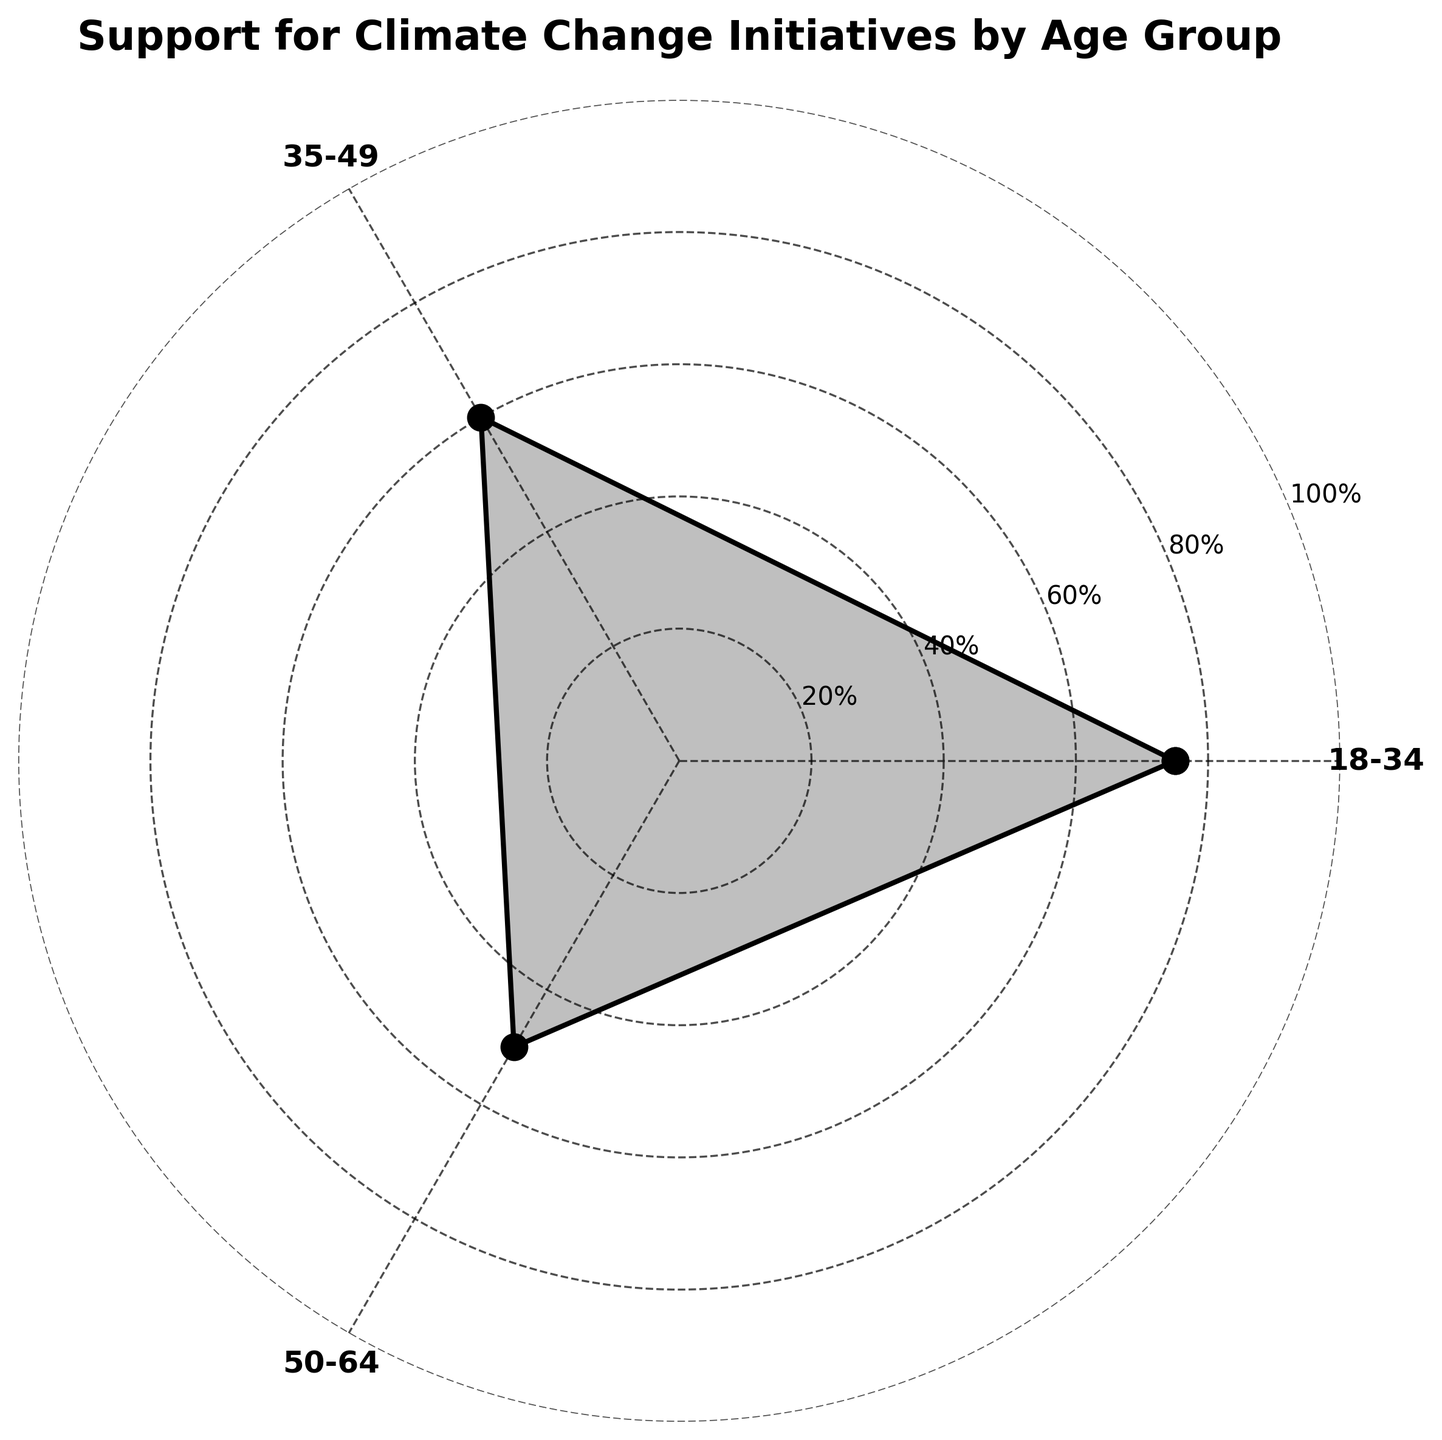What is the title of the figure? The title is displayed at the top of the figure and it reads "Support for Climate Change Initiatives by Age Group".
Answer: Support for Climate Change Initiatives by Age Group Which age group has the highest support level for climate change initiatives? By examining the plot, the highest point on the radial axis corresponds to the age group "18-34" with a support level of 75%.
Answer: 18-34 What are the age groups displayed in the rose chart? The categories along the angles show the age groups "18-34", "35-49", and "50-64".
Answer: 18-34, 35-49, 50-64 What is the support level for the age group 35-49? By looking at the position on the radial axis for the age group "35-49", the support level is shown as 60%.
Answer: 60% How many age groups are visualized in the figure? The rose chart represents three different age groups.
Answer: Three Which age group shows the least support for climate change initiatives among the visualized groups? The lowest point on the radial axis corresponds to the age group "50-64" with a support level of 50%.
Answer: 50-64 Compare the support levels of the age groups 18-34 and 35-49. Which is higher and by how much? The support level for "18-34" is 75% and for "35-49" is 60%. The difference is 75% - 60% = 15%.
Answer: 18-34 is higher by 15% Is there a noticeable trend in support levels as age increases among the displayed age groups? By observing the plot, the support level decreases as the age group increases from "18-34" to "35-49" to "50-64".
Answer: Support levels decrease as age increases What is the average support level across the displayed age groups? The support levels for the groups are 75%, 60%, and 50%. The average is calculated as (75 + 60 + 50) / 3 = 61.67%.
Answer: 61.67% If a new age group 65+ was added with a support level of 40%, how would it visually compare to the other groups in terms of support trend? Adding a 65+ group with 40% would continue the observed downward trend in support as age increases.
Answer: Continuation of decreasing trend 